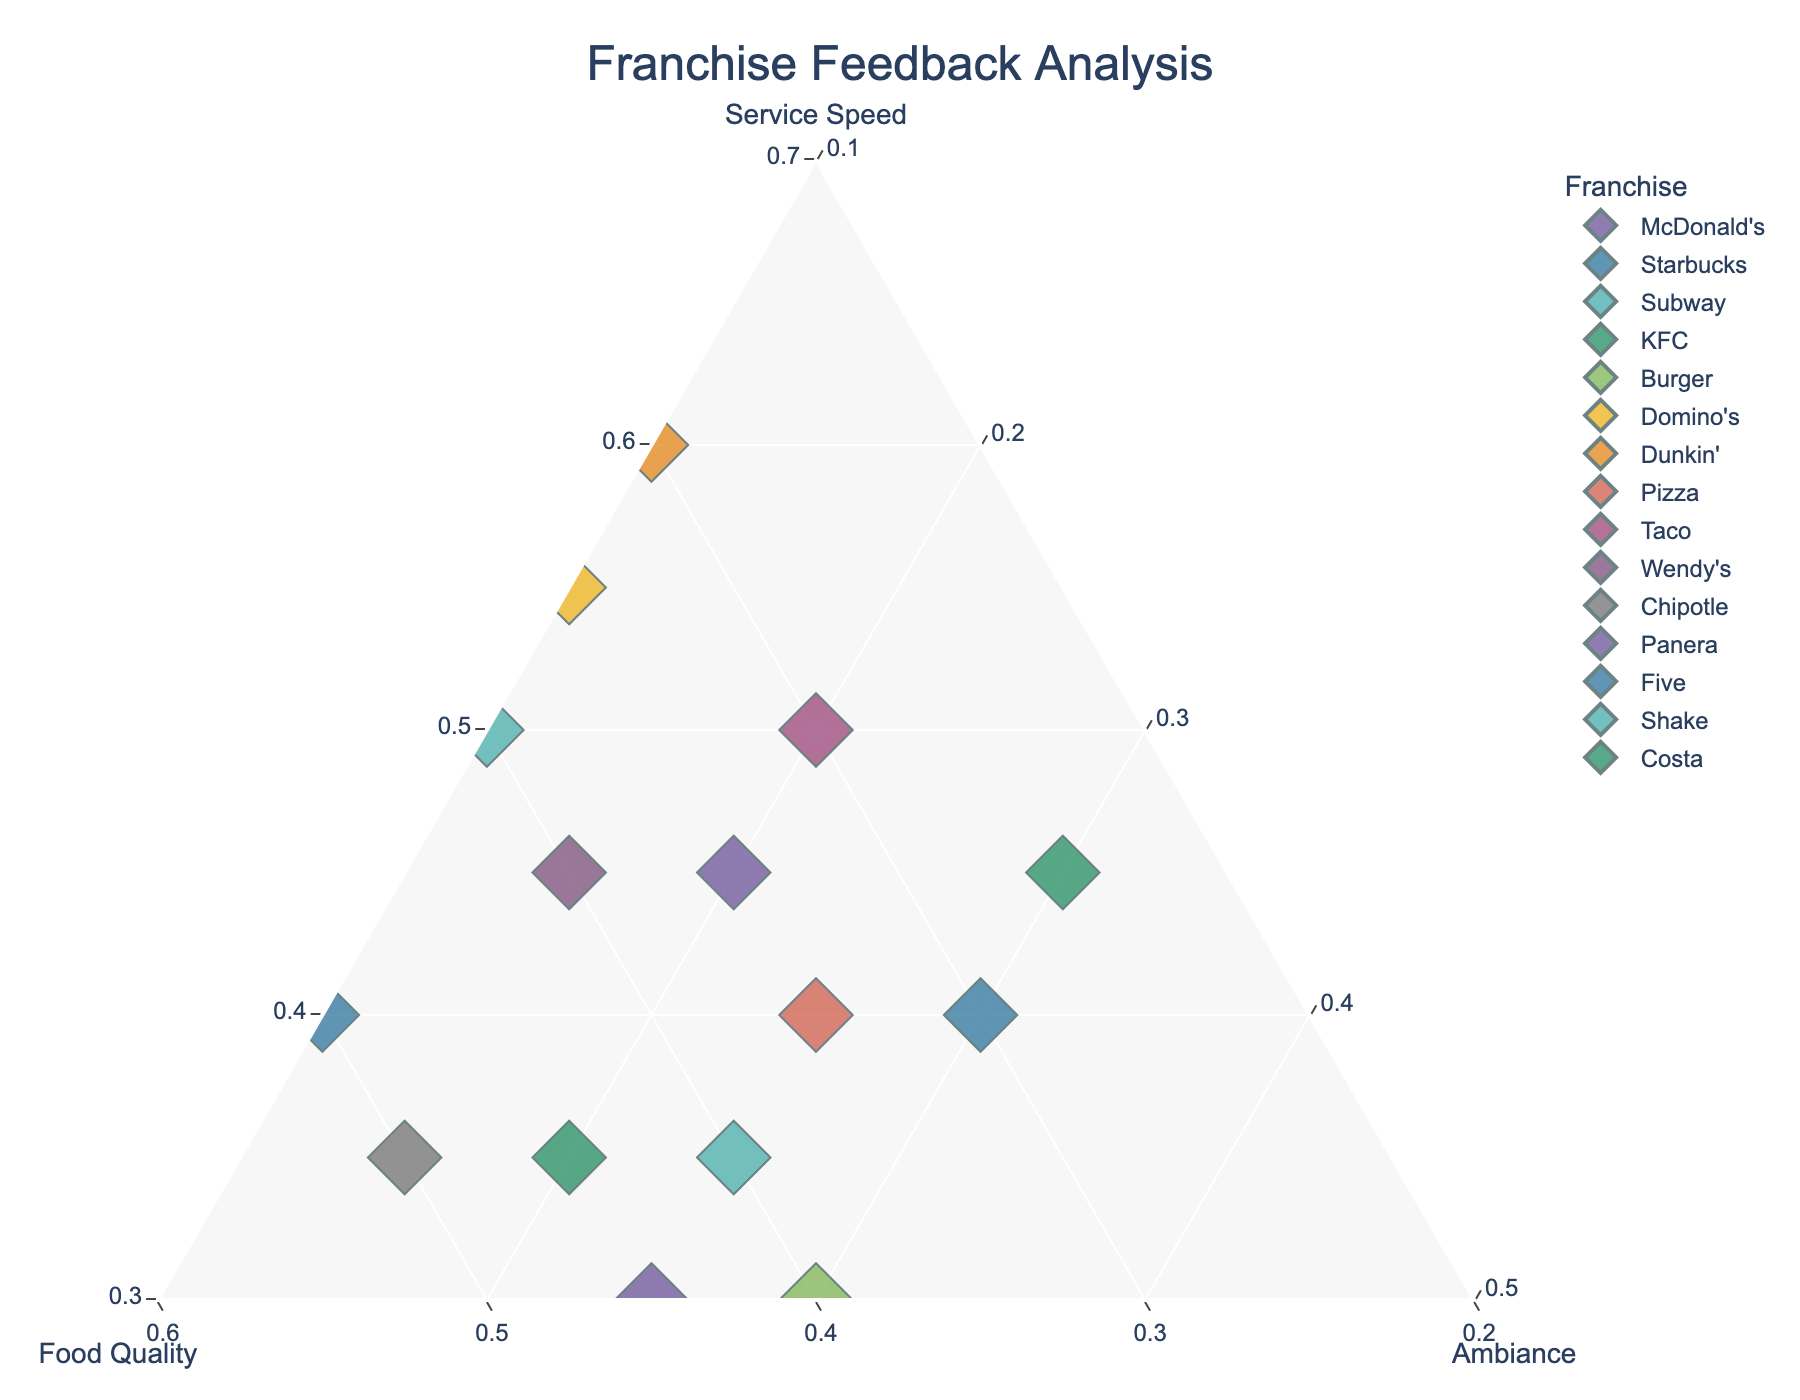What's the title of the figure? The title is usually displayed at the top center of the figure.
Answer: Franchise Feedback Analysis How many franchise locations are represented in the plot? Count the total number of data points (each representing a franchise) displayed in the plot.
Answer: 15 Which location has the highest percentage for service speed? Look for the point closest to the "Service Speed" vertex of the ternary plot.
Answer: Dunkin' Donuts Boston What are the feedback percentages for Wendy's Toronto? Identify the point representing Wendy's Toronto, then read off the corresponding proportions for Service Speed, Food Quality, and Ambiance from the plot.
Answer: 45% Service Speed, 40% Food Quality, 15% Ambiance How do McDonald's New York City and Starbucks Chicago compare in terms of ambiance? Compare the positions of the points for these two locations relative to the "Ambiance" axis.
Answer: Starbucks Chicago has a higher ambiance percentage What location has the lowest percentage in food quality? Look for the point farthest from the "Food Quality" vertex.
Answer: Costa Coffee Madrid Which three locations have the closest feedback compositions? Identify the three closest points in the plot, based on their proximity to each other.
Answer: Shake Shack Berlin, Starbucks Chicago, and Panera Bread Washington D.C Which location has an equal percentage for food quality and ambiance? Find the point where the positions relative to the "Food Quality" and "Ambiance" vertices are the same.
Answer: Burger King Paris What is the average percentage for service speed across all locations? Add all the service speed percentages and divide by the number of locations: (45 + 40 + 50 + 35 + 30 + 55 + 60 + 40 + 50 + 45 + 35 + 30 + 40 + 35 + 45) / 15
Answer: 42.33% Which location's feedback is almost equally distributed across all three categories? Look for the point near the center of the plot where all three percentages are roughly equal.
Answer: Starbucks Chicago 